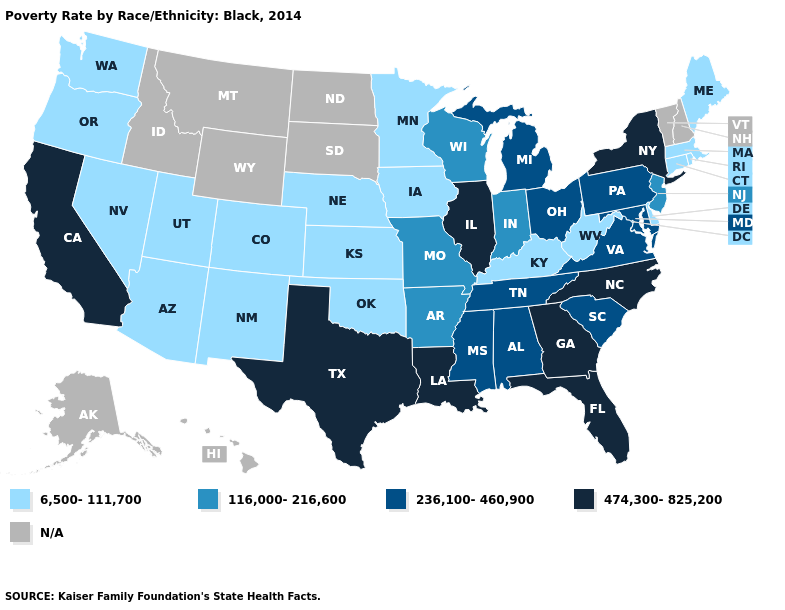Does Georgia have the highest value in the South?
Be succinct. Yes. Name the states that have a value in the range N/A?
Be succinct. Alaska, Hawaii, Idaho, Montana, New Hampshire, North Dakota, South Dakota, Vermont, Wyoming. What is the value of Oklahoma?
Answer briefly. 6,500-111,700. What is the lowest value in the South?
Keep it brief. 6,500-111,700. Name the states that have a value in the range 474,300-825,200?
Keep it brief. California, Florida, Georgia, Illinois, Louisiana, New York, North Carolina, Texas. What is the value of Kansas?
Be succinct. 6,500-111,700. What is the lowest value in states that border Wisconsin?
Short answer required. 6,500-111,700. Does the first symbol in the legend represent the smallest category?
Short answer required. Yes. Does the first symbol in the legend represent the smallest category?
Short answer required. Yes. What is the lowest value in states that border New Hampshire?
Quick response, please. 6,500-111,700. What is the lowest value in the South?
Give a very brief answer. 6,500-111,700. Does Mississippi have the lowest value in the USA?
Give a very brief answer. No. Name the states that have a value in the range 474,300-825,200?
Give a very brief answer. California, Florida, Georgia, Illinois, Louisiana, New York, North Carolina, Texas. Among the states that border Michigan , which have the lowest value?
Give a very brief answer. Indiana, Wisconsin. 